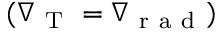Convert formula to latex. <formula><loc_0><loc_0><loc_500><loc_500>( \nabla _ { T } = \nabla _ { r a d } )</formula> 